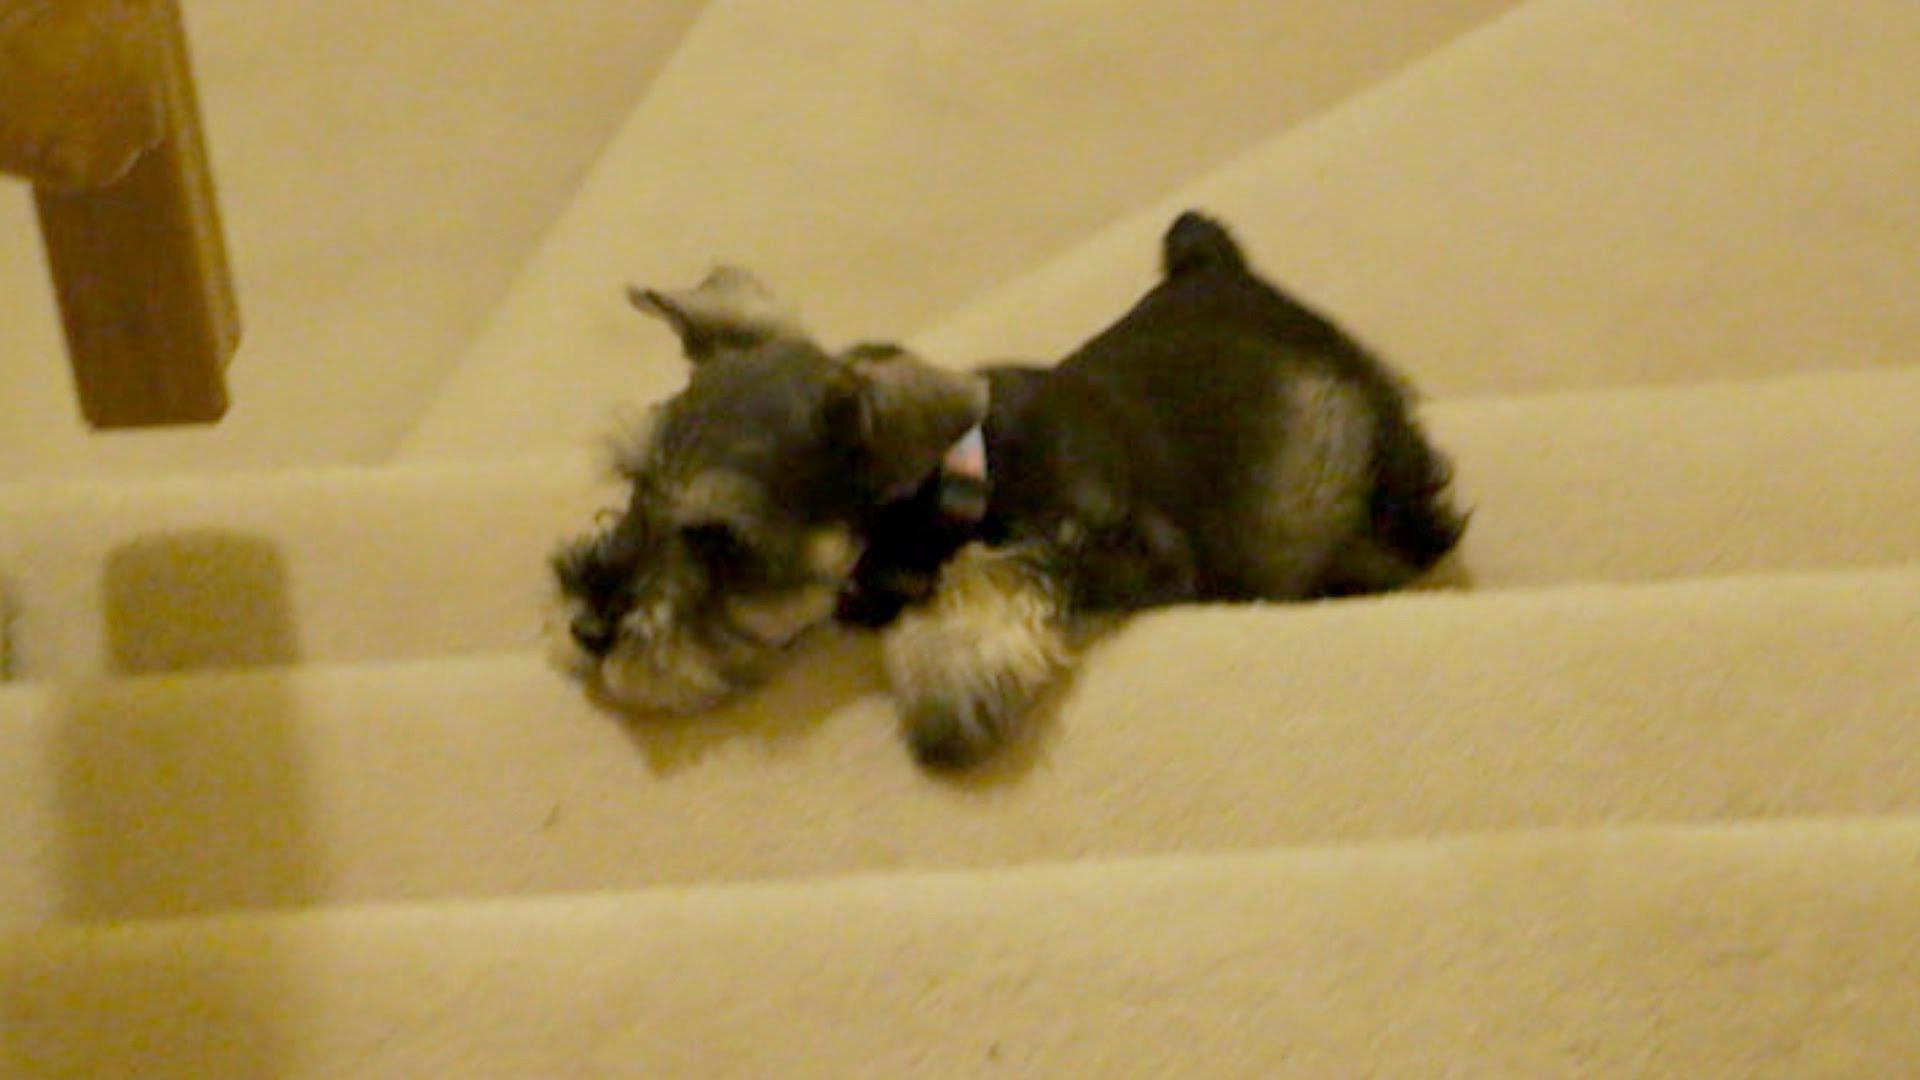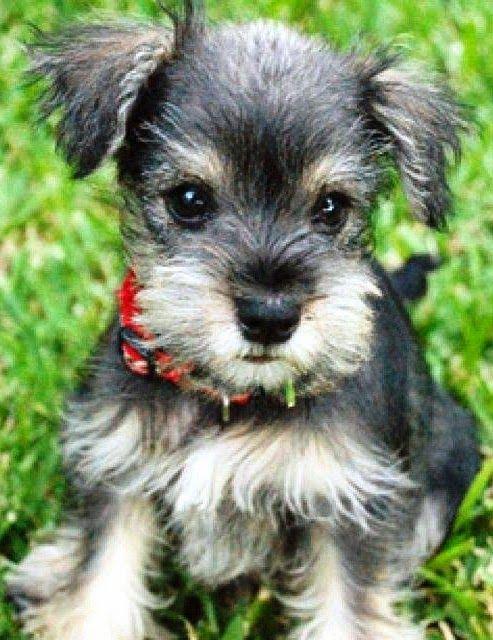The first image is the image on the left, the second image is the image on the right. For the images displayed, is the sentence "There is a single dog sitting in the grass in one of the images." factually correct? Answer yes or no. Yes. The first image is the image on the left, the second image is the image on the right. Analyze the images presented: Is the assertion "An image shows one forward facing dog wearing a red collar." valid? Answer yes or no. Yes. 